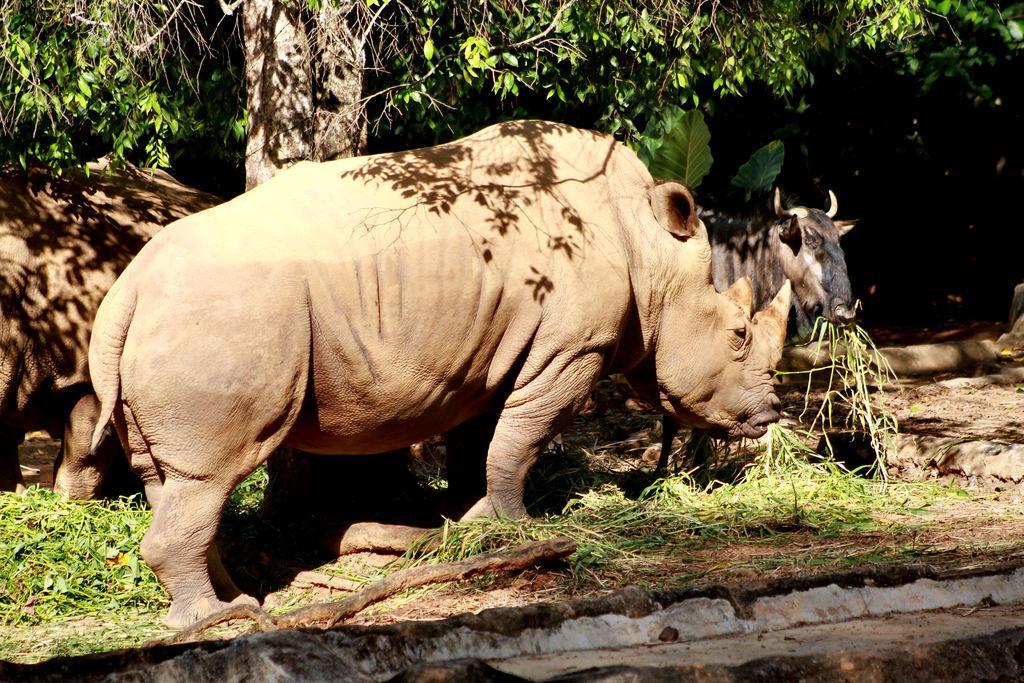Could you give a brief overview of what you see in this image? In this image we can see rhinoceros and buffalo eating grass on the ground. In the background we can see a tree and plant. 